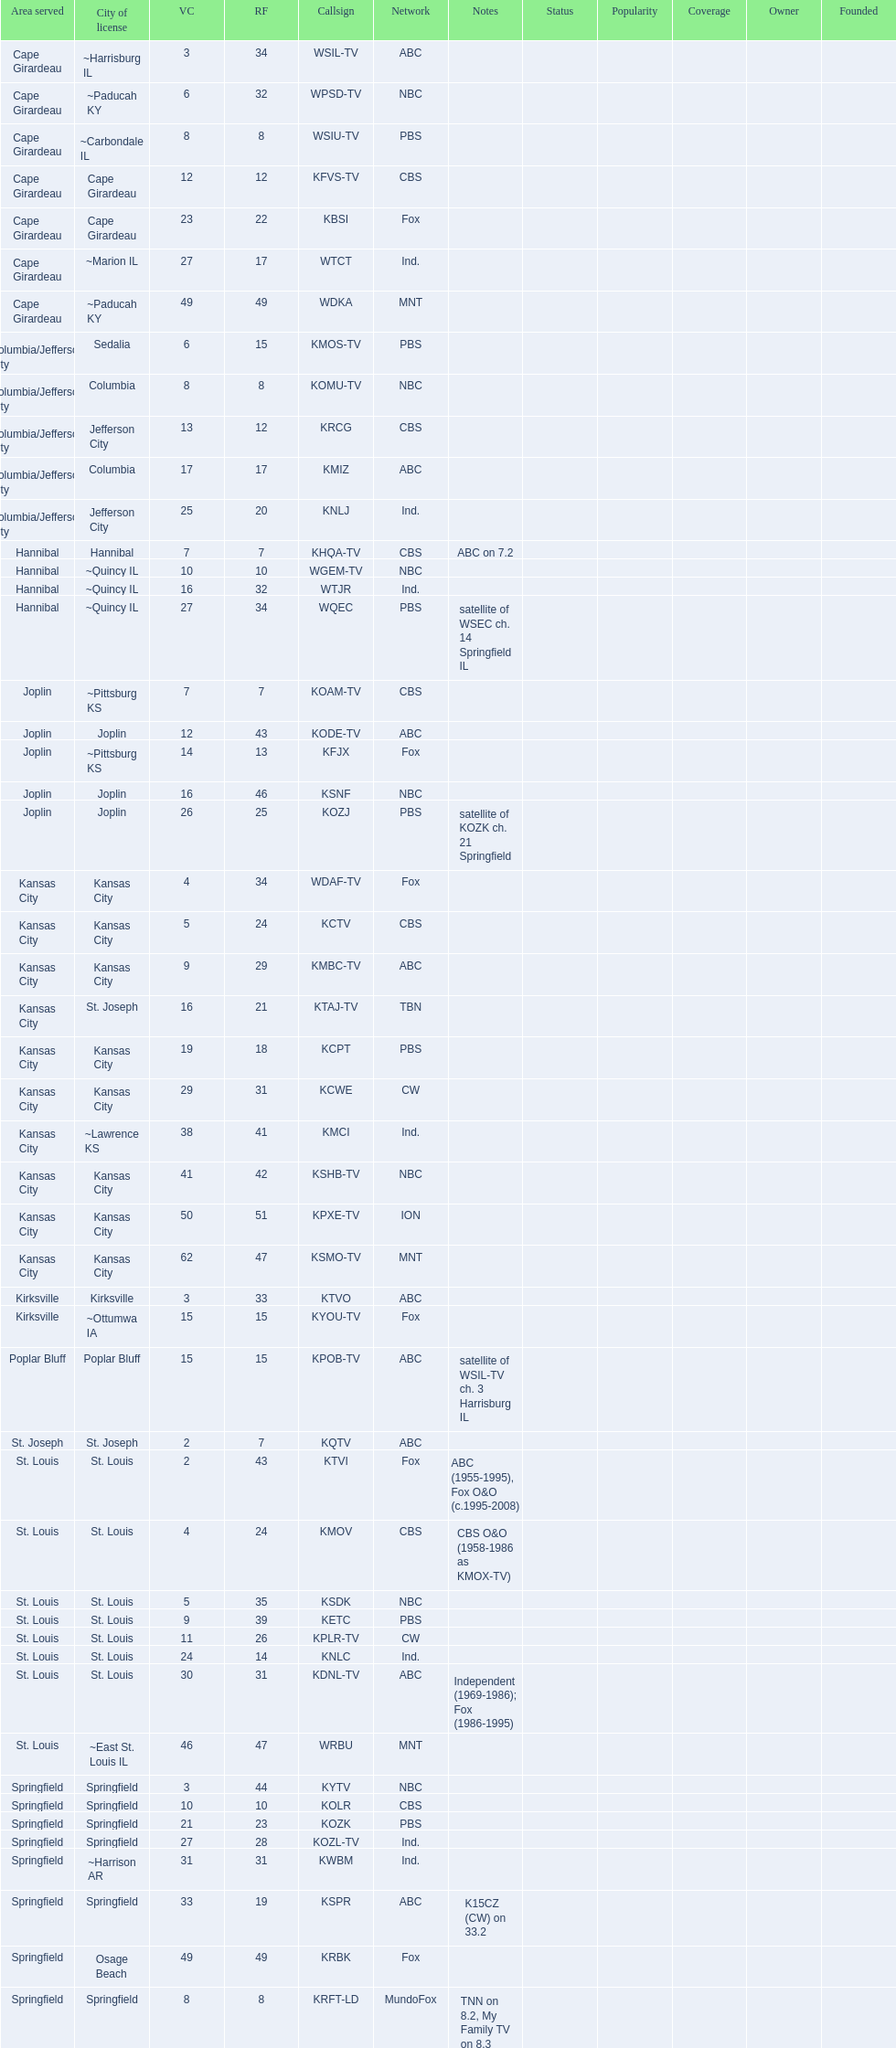How many are on the cbs network? 7. 